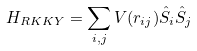Convert formula to latex. <formula><loc_0><loc_0><loc_500><loc_500>H _ { R K K Y } = \sum _ { i , j } V ( r _ { i j } ) \hat { S } _ { i } \hat { S } _ { j } \,</formula> 